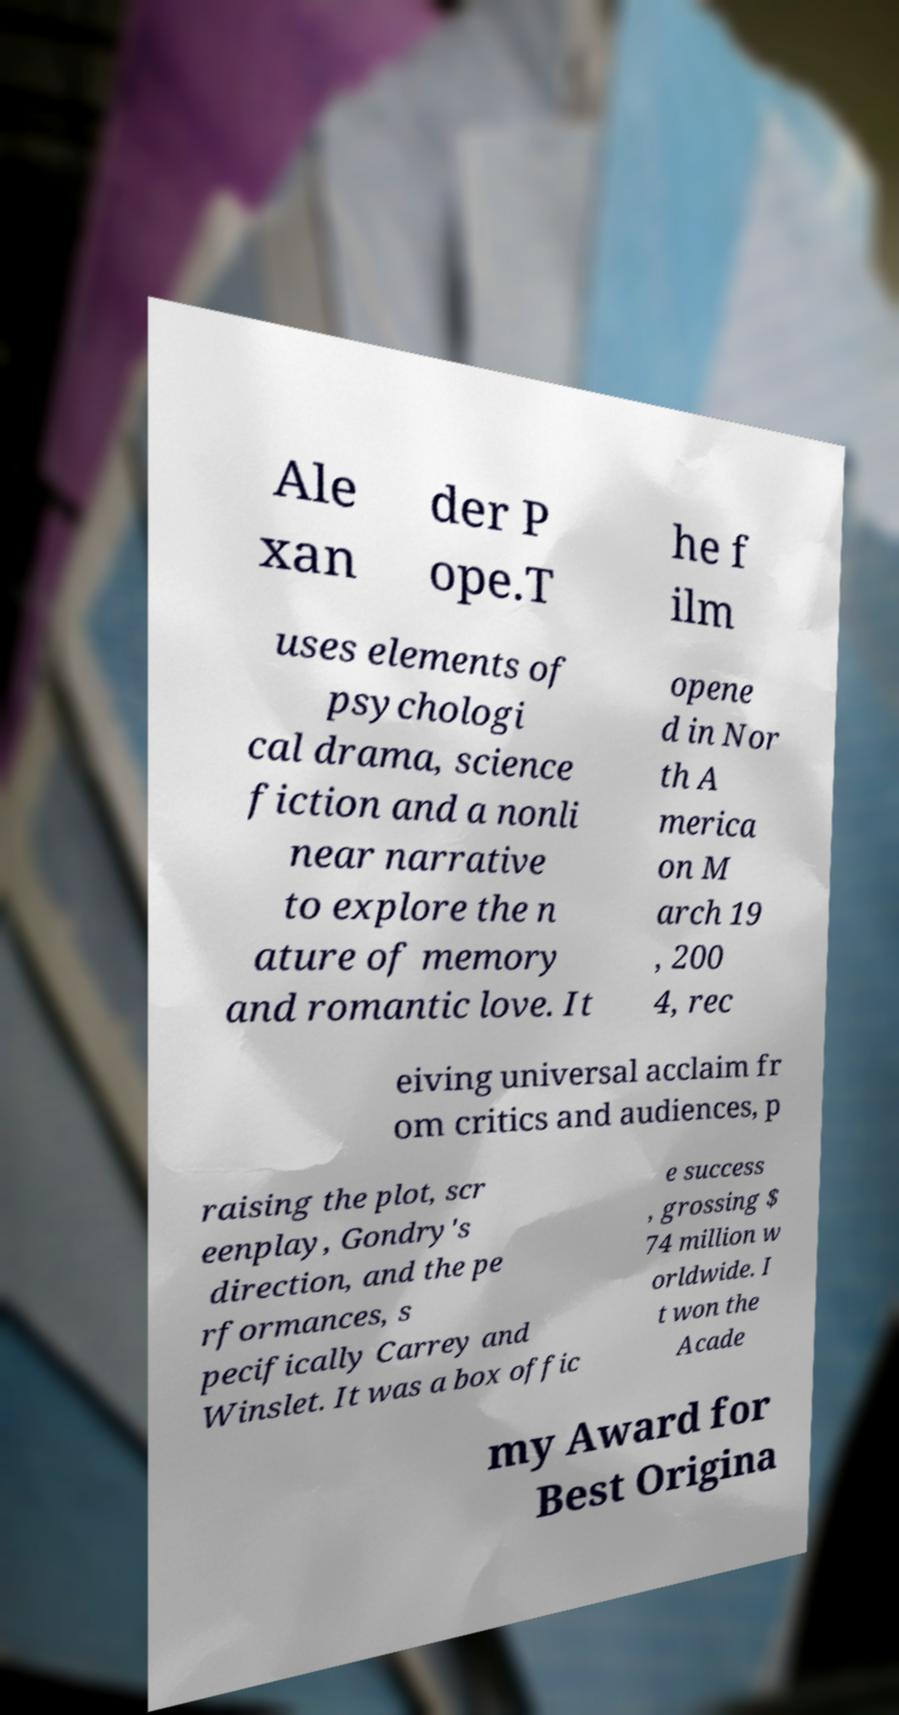Could you assist in decoding the text presented in this image and type it out clearly? Ale xan der P ope.T he f ilm uses elements of psychologi cal drama, science fiction and a nonli near narrative to explore the n ature of memory and romantic love. It opene d in Nor th A merica on M arch 19 , 200 4, rec eiving universal acclaim fr om critics and audiences, p raising the plot, scr eenplay, Gondry's direction, and the pe rformances, s pecifically Carrey and Winslet. It was a box offic e success , grossing $ 74 million w orldwide. I t won the Acade my Award for Best Origina 